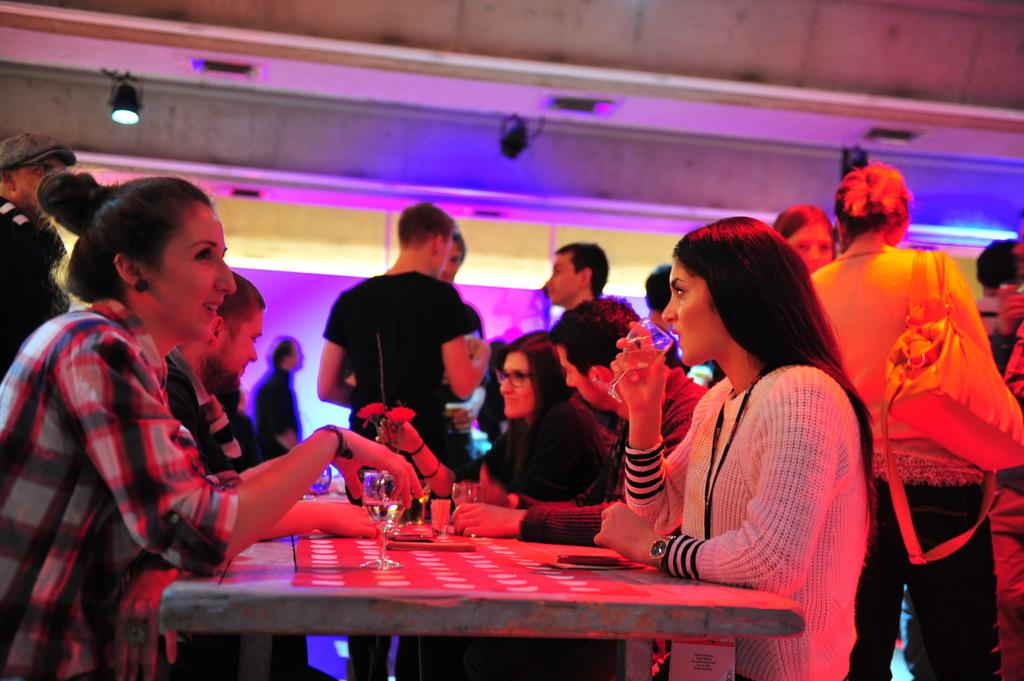Who is present in the image? There are people in the image. What are the people doing in the image? The people are sitting around a table. What objects can be seen on the table? There are glasses on the table. What type of skirt is the chair wearing in the image? There is no chair wearing a skirt in the image; chairs do not wear clothing. 